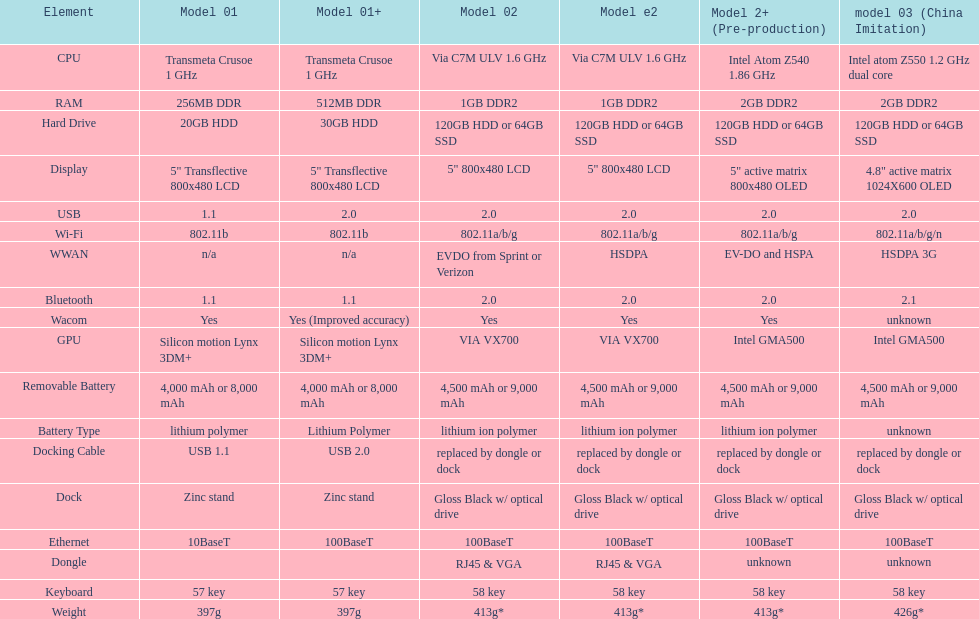Are there at least 13 different components on the chart? Yes. 